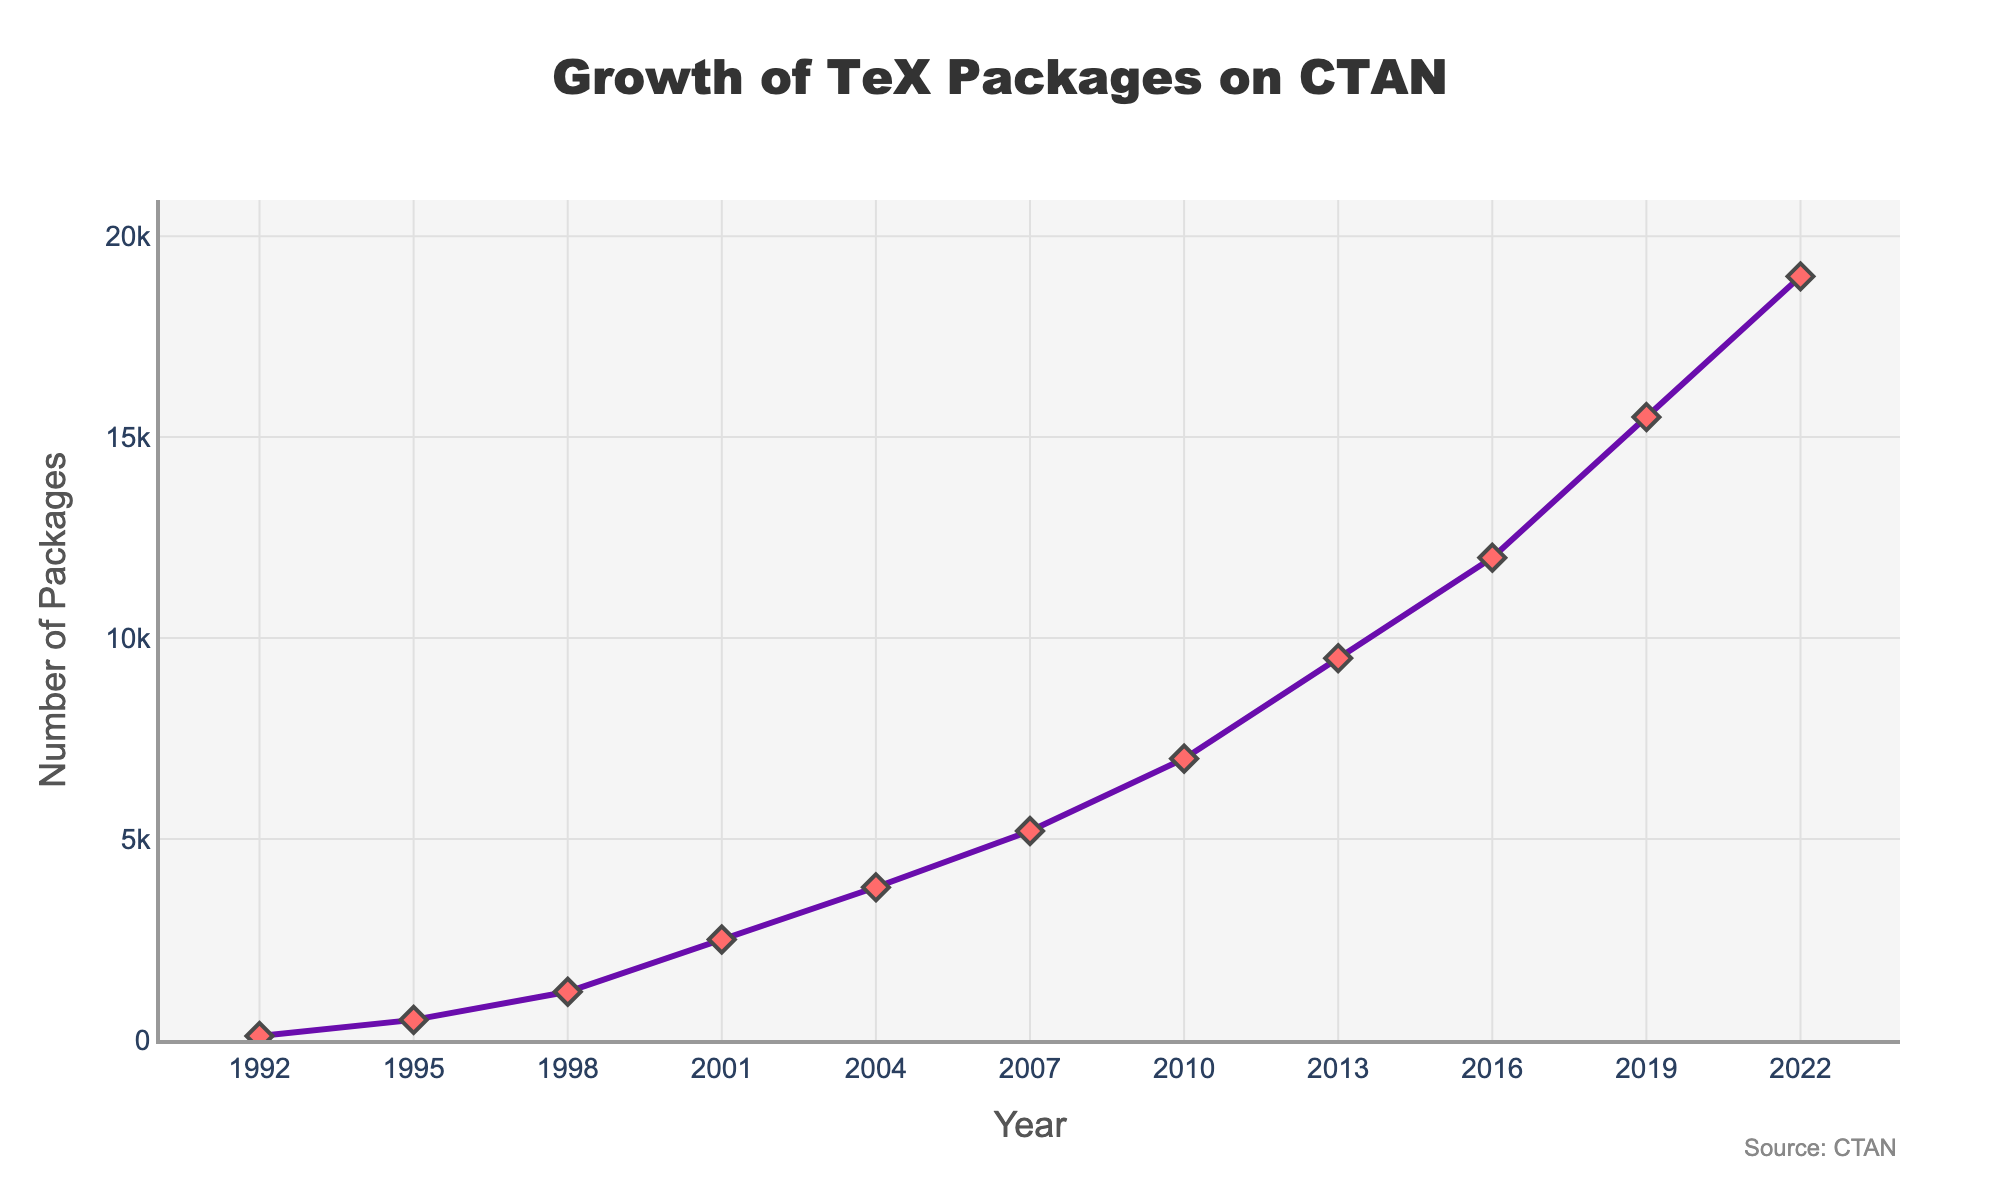What is the number of TeX-related packages available on CTAN in 2010? To find the number of packages available in 2010, look at the data point corresponding to the year 2010 on the x-axis and check the y-axis value. The plot indicates there were 7000 packages available in 2010.
Answer: 7000 Between which years did the number of TeX-related packages triple? Check the data points to find when the number of packages tripled. For example, from 1992 (100 packages) to 1998 (1200 packages), the number of packages more than tripled (100*3 = 300).
Answer: 1992 to 1998 What is the average number of TeX-related packages available from 1998 to 2007? First, add the number of packages for the years 1998 (1200), 2001 (2500), 2004 (3800), and 2007 (5200). Then, divide by the number of years, which is 4. The calculation is (1200 + 2500 + 3800 + 5200) / 4 = 3175.
Answer: 3175 Which year experienced the highest number of new package additions compared to its previous count? By examining the difference between consecutive years, the highest increase is from 2010 to 2013 (9500 - 7000 = 2500).
Answer: 2013 What was the percentage increase in the number of packages from 1995 to 2001? Measure the increase from 500 (in 1995) to 2500 (in 2001). Percentage increase is ((2500 - 500) / 500) * 100 = 400%.
Answer: 400% In which period did the number of TeX-related packages double the quickest? Find periods where the packages doubled and compare their durations. From 2004 (3800) to 2010 (7000), there is a noticeable increase; however, from 1992 (100) to 1995 (500), the duration is shorter and the number exceeds double.
Answer: 1992 to 1995 What was the growth rate from 2007 to 2022 in the number of packages? Calculate the overall growth from 5200 in 2007 to 19000 in 2022. Growth rate is ((19000 - 5200) / 5200) * 100% ≈ 265%.
Answer: 265% What is the trend of the number of packages from 2013 to 2022? The trend can be deduced by drawing a mental line from the data point in 2013 (9500) to 2022 (19000). The number steadily increases.
Answer: Increasing How does the number of packages in 2001 compare to the number in 2004? Simply comparing the 2001 (2500) and 2004 (3800) values indicates that there is a significant increase in the number of packages from 2500 to 3800.
Answer: Increased Between which years did the number of packages reach a landmark figure of 10,000? By observing the data points, between 2010 (7000) and 2013 (9500), the number surpassed 10,000.
Answer: Between 2010 and 2013 